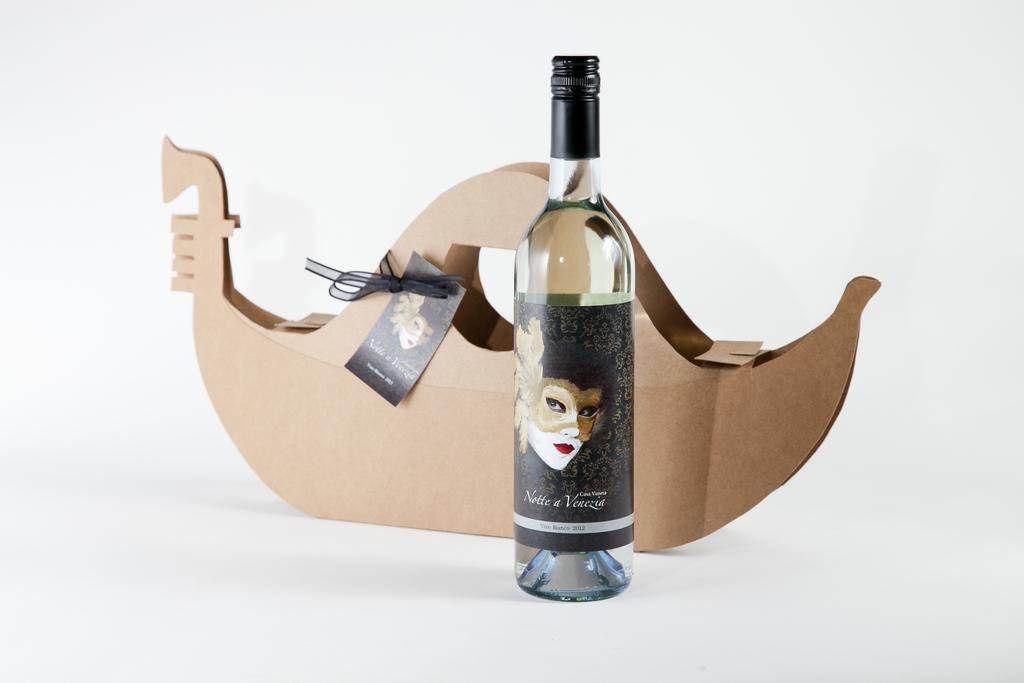What is the main object in the image? There is a wine bottle in the image. Are there any additional features on the wine bottle? Yes, there is a woman sticker on the bottle. What can be seen behind the wine bottle? There is a boat-shaped box behind the bottle. What grade does the woman sticker on the wine bottle receive? There is no indication of a grade or evaluation on the woman sticker in the image. How many fingers can be seen holding the wine bottle? There are no fingers visible in the image, as it only shows the wine bottle and the woman sticker. 